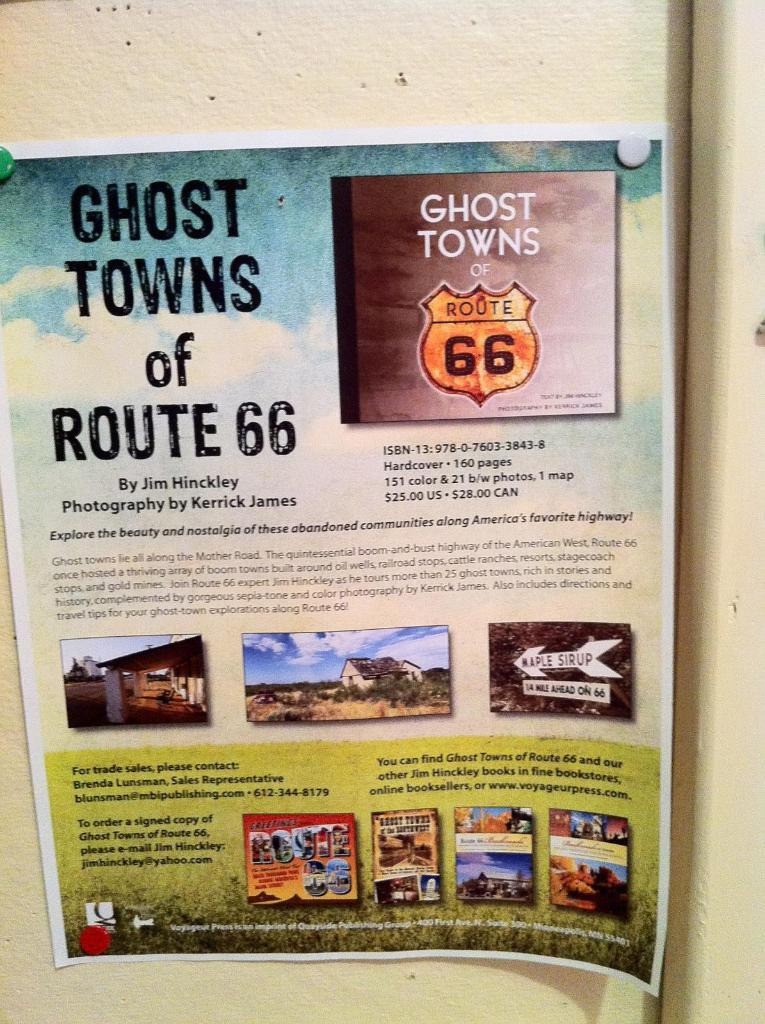<image>
Provide a brief description of the given image. a magazine with route 66 on the front of it 